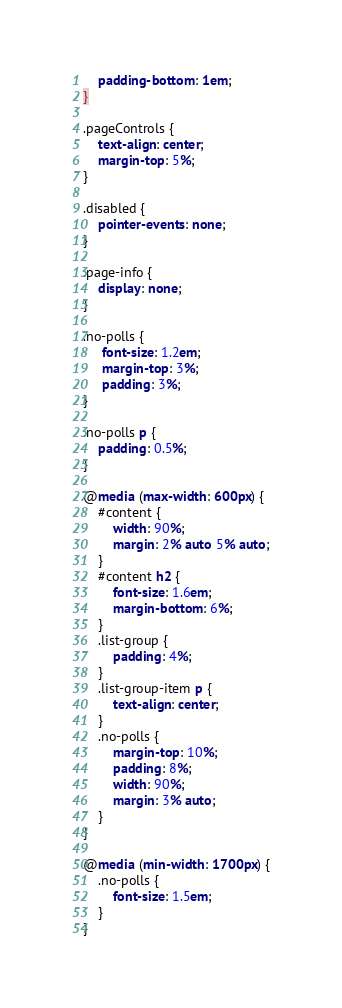Convert code to text. <code><loc_0><loc_0><loc_500><loc_500><_CSS_>    padding-bottom: 1em;
}

.pageControls {
    text-align: center;
    margin-top: 5%;
}

.disabled {
    pointer-events: none;
}

.page-info {
    display: none;
}

.no-polls {
     font-size: 1.2em;
     margin-top: 3%;
     padding: 3%;
}

.no-polls p {
    padding: 0.5%;
}

@media (max-width: 600px) {
    #content {
        width: 90%;
        margin: 2% auto 5% auto;
    }
    #content h2 {
        font-size: 1.6em;
        margin-bottom: 6%;
    }
    .list-group {
        padding: 4%;
    }
    .list-group-item p {
        text-align: center;
    }
    .no-polls {
        margin-top: 10%;
        padding: 8%;
        width: 90%;
        margin: 3% auto;
    }
}

@media (min-width: 1700px) {
    .no-polls {
        font-size: 1.5em;
    }
}
</code> 